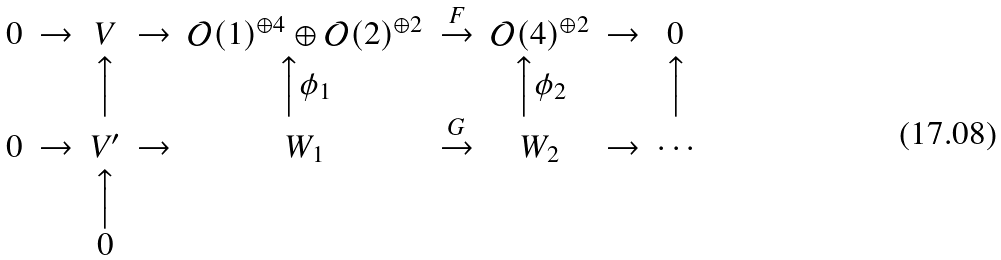<formula> <loc_0><loc_0><loc_500><loc_500>\begin{array} { c c c c c c c c c } 0 & \rightarrow & V & \rightarrow & \mathcal { O } ( 1 ) ^ { \oplus 4 } \oplus \mathcal { O } ( 2 ) ^ { \oplus 2 } & \stackrel { F } { \rightarrow } & \mathcal { O } ( 4 ) ^ { \oplus 2 } & \rightarrow & 0 \\ & & \Big \uparrow & & \Big \uparrow \phi _ { 1 } & & \Big \uparrow \phi _ { 2 } & & \Big \uparrow \\ 0 & \rightarrow & V ^ { \prime } & \rightarrow & W _ { 1 } & \stackrel { G } { \rightarrow } & W _ { 2 } & \rightarrow & \cdots \\ & & \Big \uparrow & & & & & & \\ & & 0 & & & & & & \end{array}</formula> 